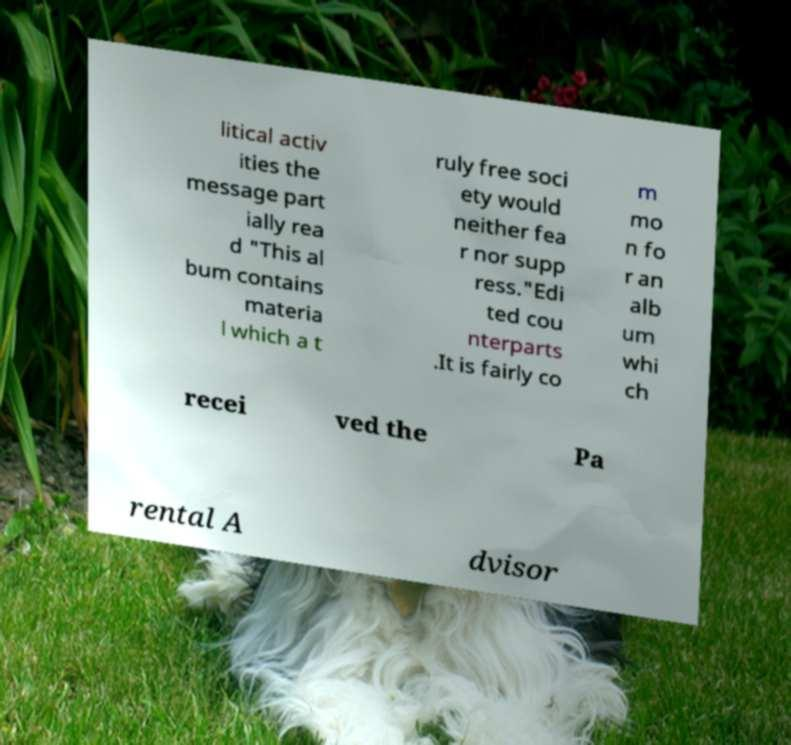I need the written content from this picture converted into text. Can you do that? litical activ ities the message part ially rea d "This al bum contains materia l which a t ruly free soci ety would neither fea r nor supp ress."Edi ted cou nterparts .It is fairly co m mo n fo r an alb um whi ch recei ved the Pa rental A dvisor 